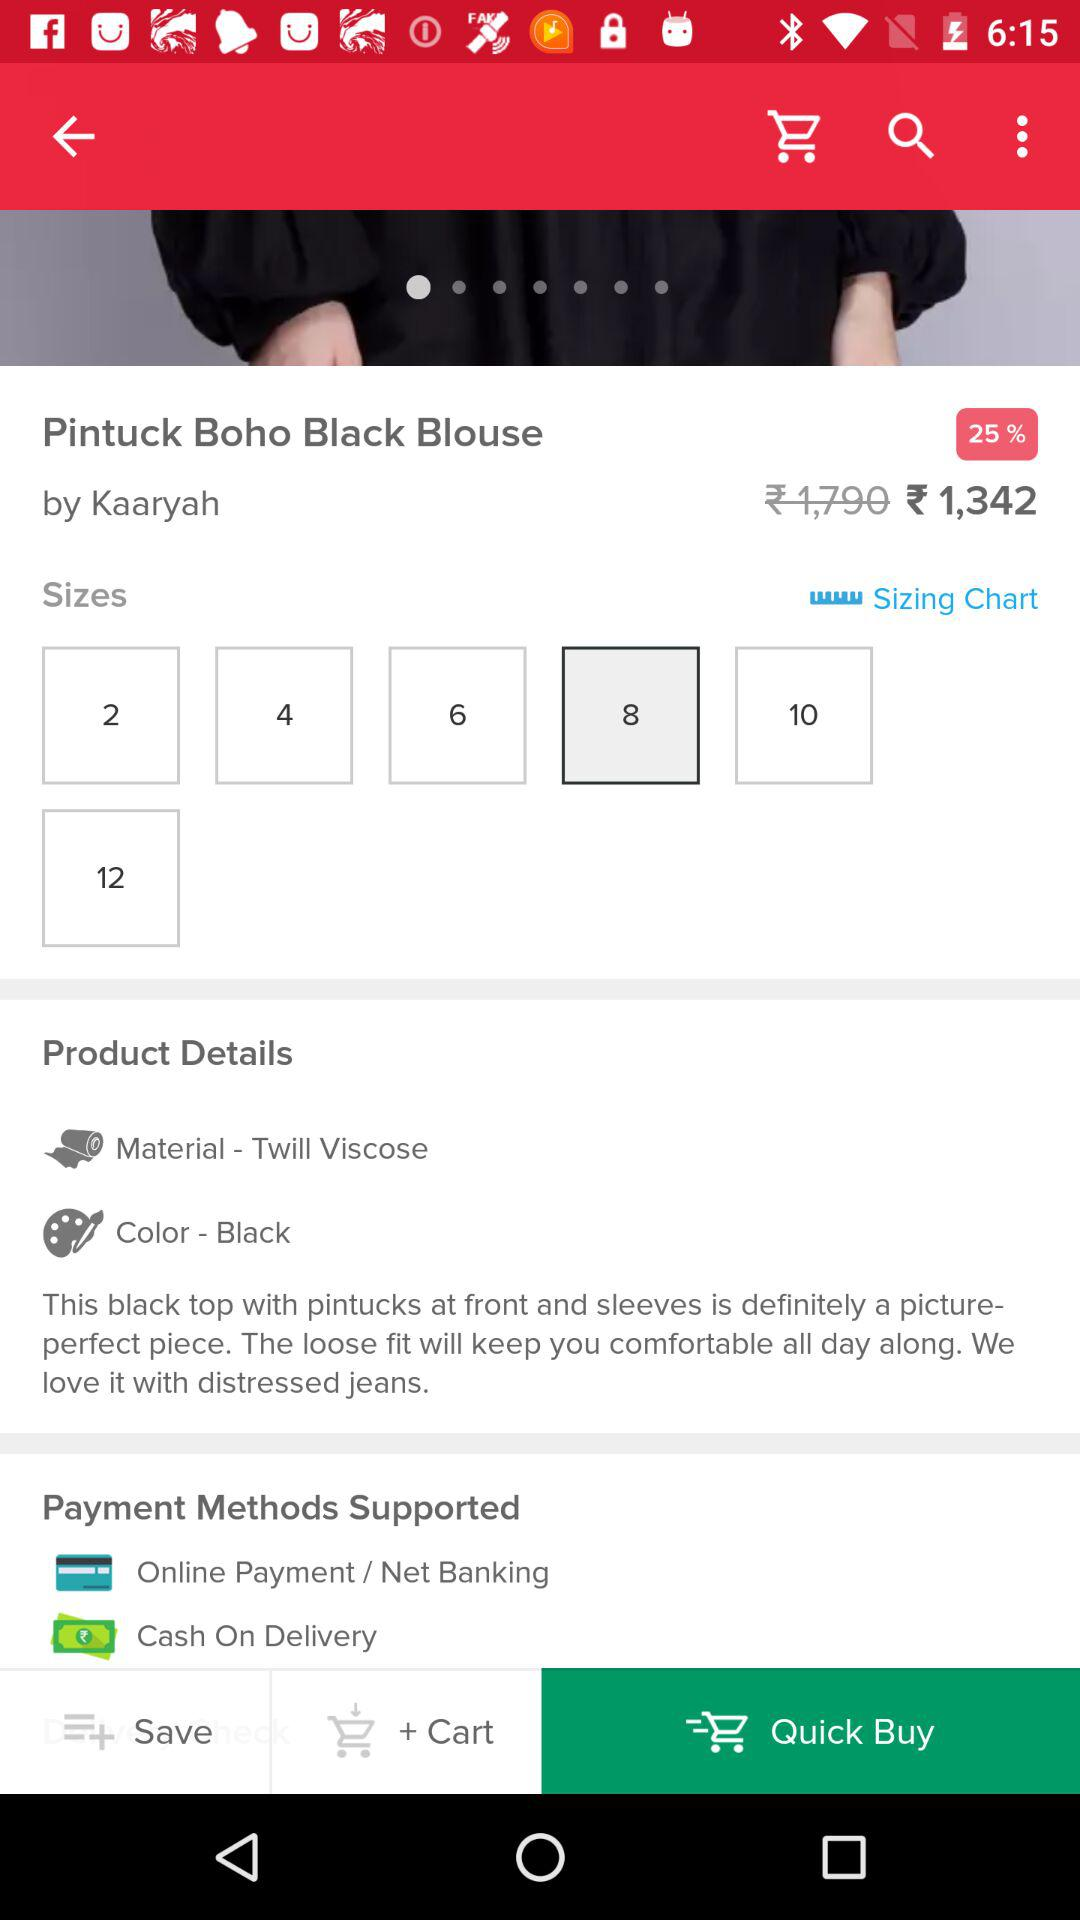What size is available for the blouse? The available sizes for the blouse are 2,4,6,8,10, and 12. 